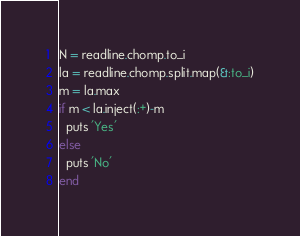Convert code to text. <code><loc_0><loc_0><loc_500><loc_500><_Ruby_>N = readline.chomp.to_i
la = readline.chomp.split.map(&:to_i)
m = la.max
if m < la.inject(:+)-m
  puts 'Yes'
else
  puts 'No'
end
</code> 